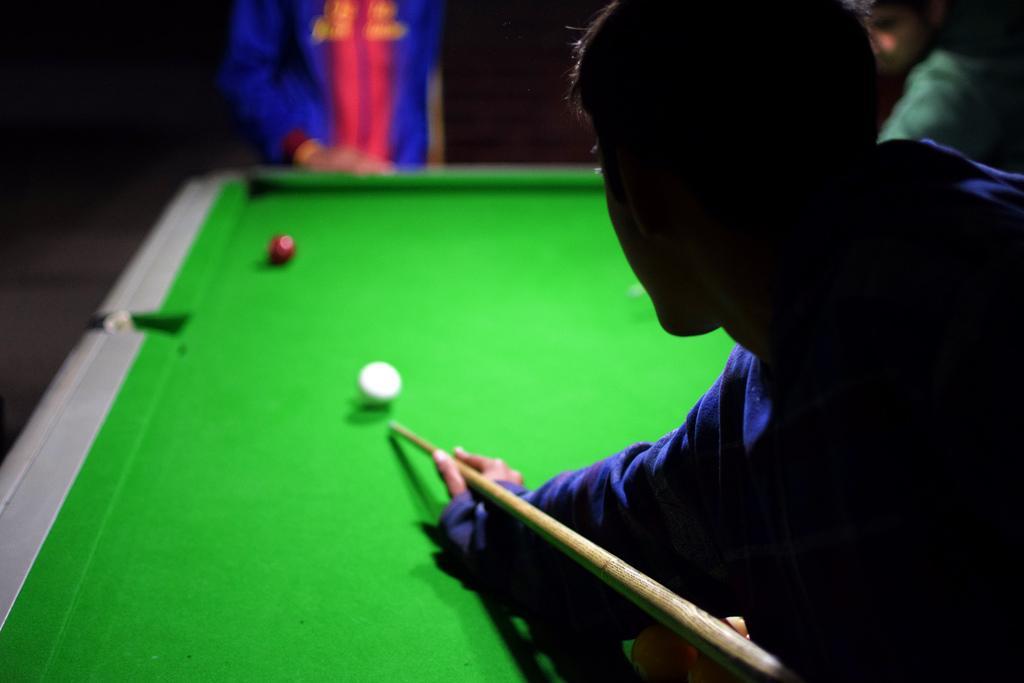In one or two sentences, can you explain what this image depicts? In this picture I can see three persons, there is a person holding a cue stick, there are billiard balls on the snooker table. 